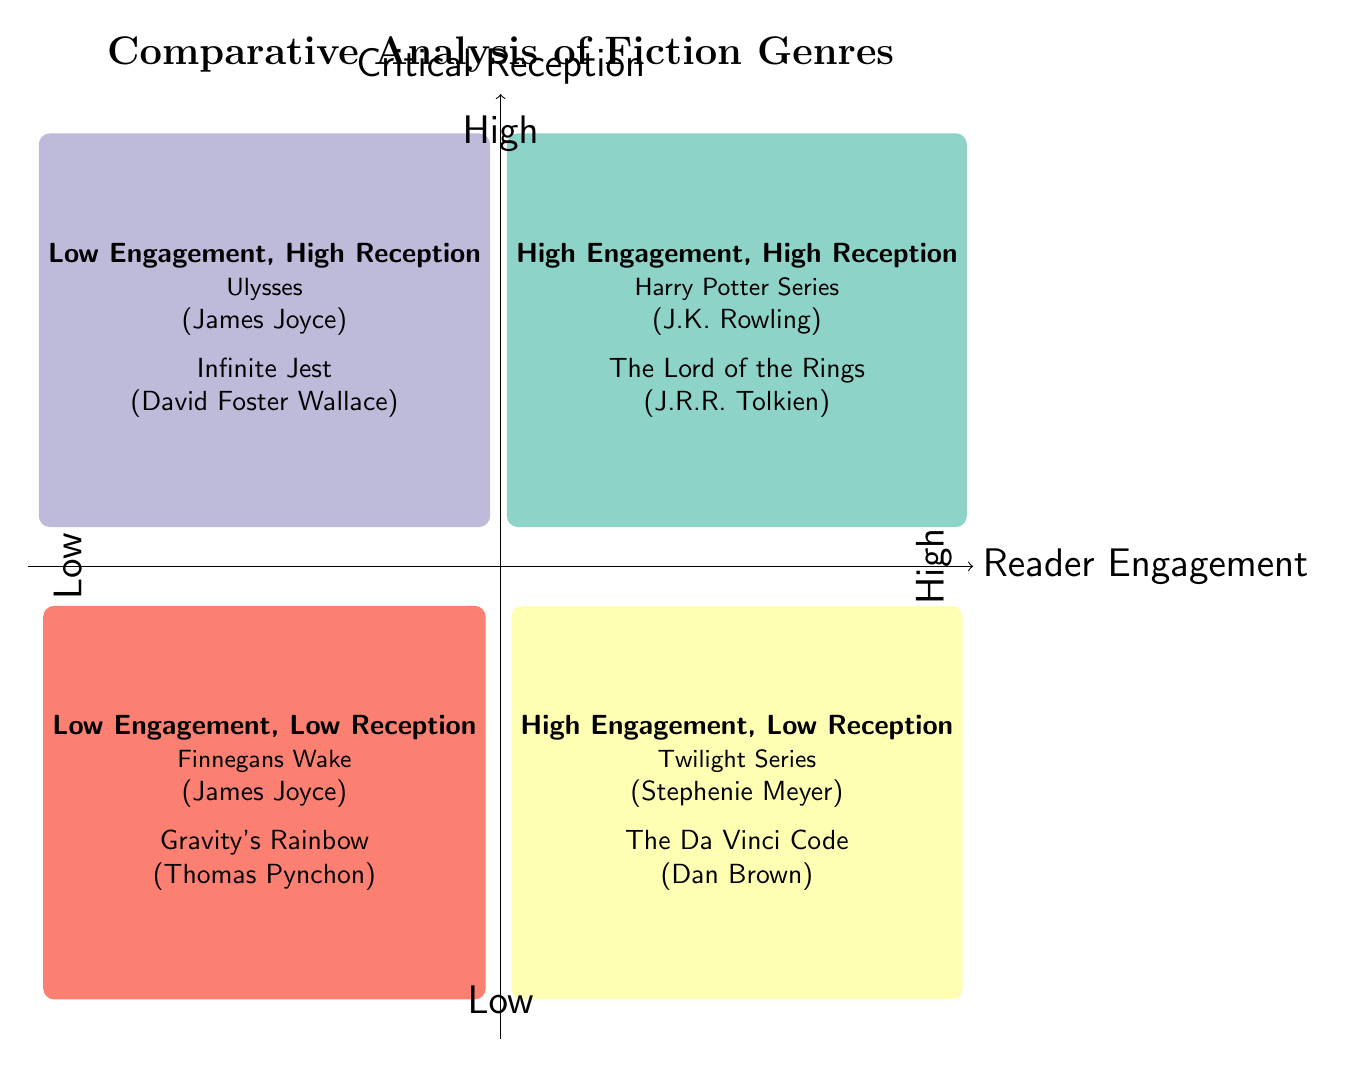What are the two titles in the High Engagement, High Reception quadrant? The High Engagement, High Reception quadrant lists two titles: "Harry Potter Series" and "The Lord of the Rings".
Answer: Harry Potter Series, The Lord of the Rings Which author is associated with "Ulysses"? "Ulysses" is located in the Low Engagement, High Reception quadrant, and is authored by James Joyce.
Answer: James Joyce How many titles are shown in the High Engagement, Low Reception quadrant? The High Engagement, Low Reception quadrant contains two titles: "Twilight Series" and "The Da Vinci Code". Therefore, the count is two.
Answer: 2 Name a title that falls into the Low Engagement, Low Reception quadrant. The Low Engagement, Low Reception quadrant includes "Finnegans Wake" as one of its titles.
Answer: Finnegans Wake Which quadrant contains works with both low engagement and high critical reception? The quadrant that represents low engagement and high critical reception is named "Low Engagement, High Reception".
Answer: Low Engagement, High Reception What is the relationship between reader engagement and critical reception for "Twilight Series"? "Twilight Series" is located in the High Engagement, Low Reception quadrant, indicating that it has high reader engagement but low critical reception.
Answer: High Engagement, Low Reception How many quadrants are represented in the diagram? The diagram illustrates four distinct quadrants, each with its unique characteristics regarding reader engagement and critical reception.
Answer: 4 Which genre does "Gravity's Rainbow" belong to in this chart? "Gravity's Rainbow" is located in the Low Engagement, Low Reception quadrant, indicating it belongs to that particular category of genre perception.
Answer: Low Engagement, Low Reception 